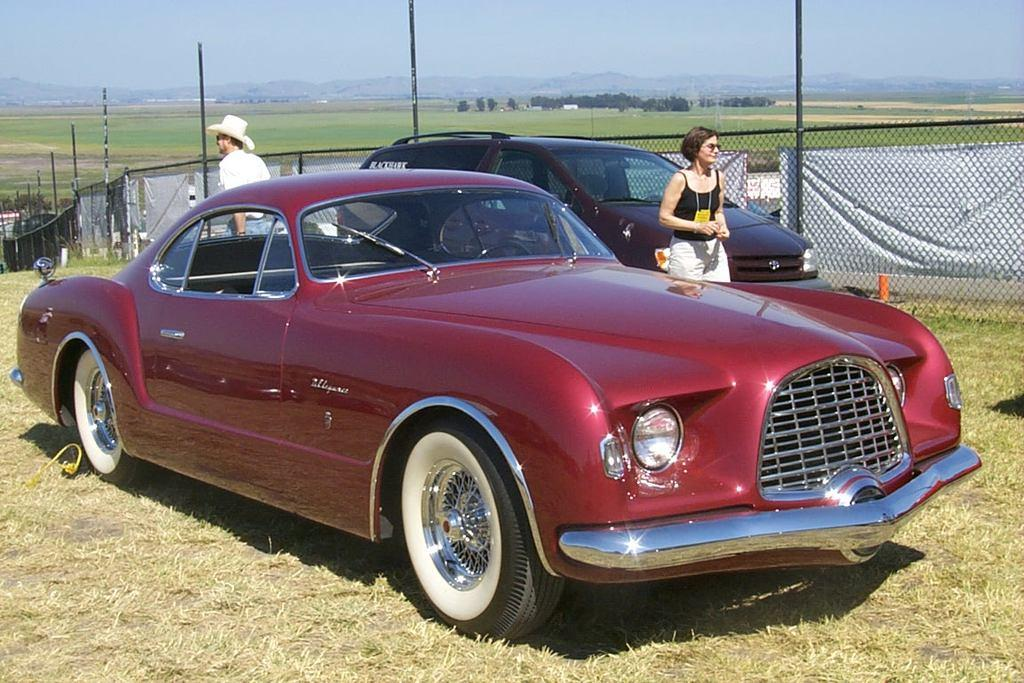How many vehicles are in the image? There are two vehicles in the image. What can be seen behind the vehicles? There are two persons behind the vehicles. What type of structures are visible in the image? There are poles and fencing visible in the image. What type of natural environment is present in the image? Grass, a group of trees, and mountains are visible in the image. What is visible at the top of the image? The sky is visible at the top of the image. What type of arch can be seen in the image? There is no arch present in the image. What is the name of the daughter of the person standing behind the vehicle? There is no information about a daughter in the image, and the person's name is not mentioned. 